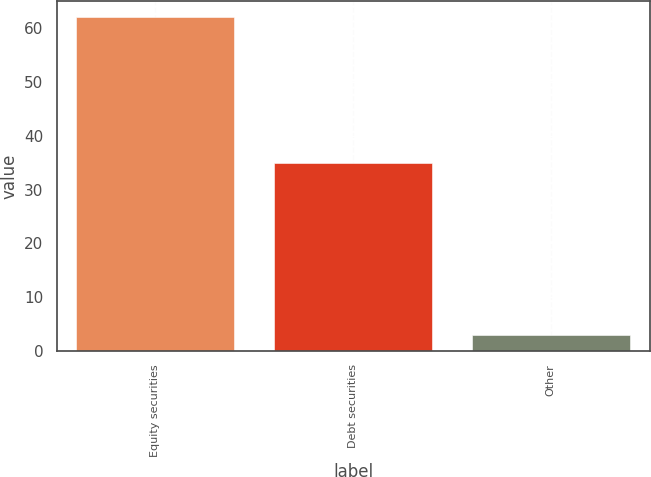Convert chart. <chart><loc_0><loc_0><loc_500><loc_500><bar_chart><fcel>Equity securities<fcel>Debt securities<fcel>Other<nl><fcel>62<fcel>35<fcel>3<nl></chart> 